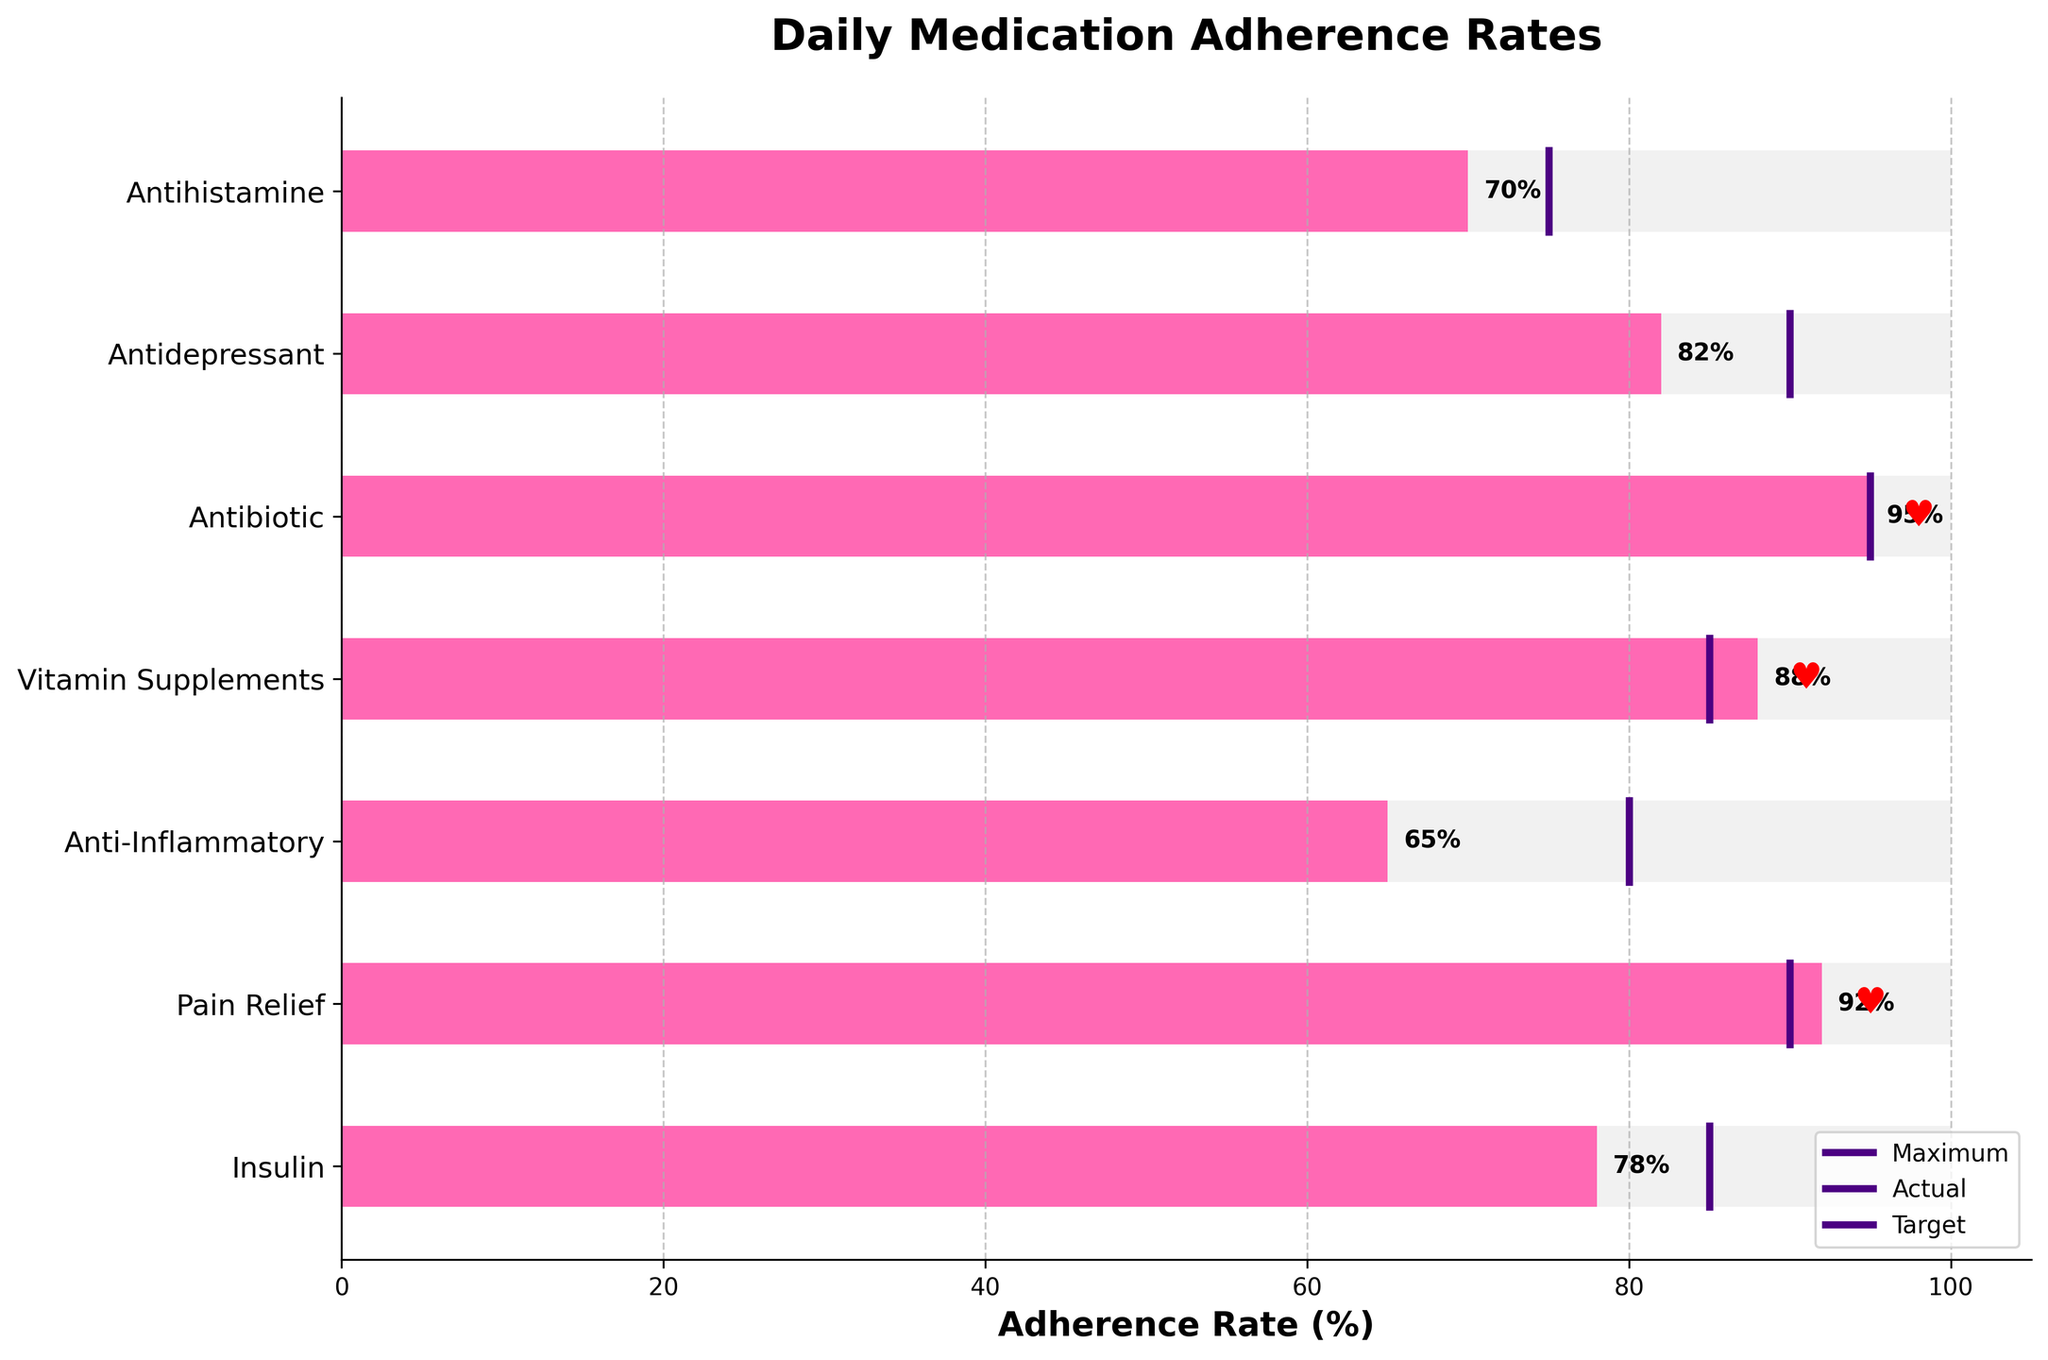How many medications are shown in the bullet chart? Count the number of distinct medications listed on the y-axis. There are 7 medications: Insulin, Pain Relief, Anti-Inflammatory, Vitamin Supplements, Antibiotic, Antidepressant, Antihistamine.
Answer: 7 What is the title of the chart? Look at the top of the chart where the title is displayed. The title is "Daily Medication Adherence Rates."
Answer: Daily Medication Adherence Rates Which medication has the highest actual adherence rate? Compare the actual adherence rates of all medications. The highest actual adherence rate is 95, and it is for Antibiotic.
Answer: Antibiotic Is the actual adherence rate for Insulin greater than or equal to its target adherence rate? Check the actual adherence (78) and compare it with the target adherence (85) for Insulin. 78 is less than 85.
Answer: No Which medications have achieved or exceeded their target adherence rate? Identify the medications where the actual adherence rate is greater than or equal to the target adherence rate. Antibiotic (95 = 95) and Pain Relief (92 >= 90) have met or exceeded their targets.
Answer: Antibiotic, Pain Relief What is the average actual adherence rate for all medications? Sum all actual adherence rates and divide by the number of medications. (78 + 92 + 65 + 88 + 95 + 82 + 70) / 7 = 570 / 7 = 81.4
Answer: 81.4 Which medication has the largest gap between its actual adherence rate and target adherence rate? Calculate the difference between actual and target adherence rates for each medication. The largest gap is for Anti-Inflammatory: 80 - 65 = -15 (in absolute value, it's 15).
Answer: Anti-Inflammatory Are there any medications where the actual adherence is exactly equal to the target adherence? Compare the actual and target adherence rates for equality. Antibiotic has an actual adherence of 95, which is equal to its target adherence of 95.
Answer: Yes, Antibiotic Which medication has the lowest target adherence rate? Compare all target adherence rates and identify the lowest one. Antihistamine has the lowest target adherence rate of 75.
Answer: Antihistamine 